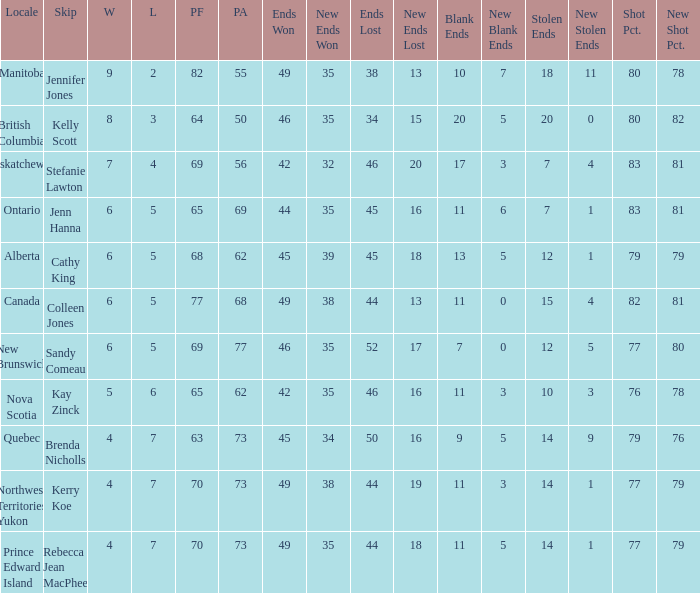What is the minimum PA when ends lost is 45? 62.0. Could you parse the entire table as a dict? {'header': ['Locale', 'Skip', 'W', 'L', 'PF', 'PA', 'Ends Won', 'New Ends Won', 'Ends Lost', 'New Ends Lost', 'Blank Ends', 'New Blank Ends', 'Stolen Ends', 'New Stolen Ends', 'Shot Pct.', 'New Shot Pct.'], 'rows': [['Manitoba', 'Jennifer Jones', '9', '2', '82', '55', '49', '35', '38', '13', '10', '7', '18', '11', '80', '78'], ['British Columbia', 'Kelly Scott', '8', '3', '64', '50', '46', '35', '34', '15', '20', '5', '20', '0', '80', '82'], ['Saskatchewan', 'Stefanie Lawton', '7', '4', '69', '56', '42', '32', '46', '20', '17', '3', '7', '4', '83', '81'], ['Ontario', 'Jenn Hanna', '6', '5', '65', '69', '44', '35', '45', '16', '11', '6', '7', '1', '83', '81'], ['Alberta', 'Cathy King', '6', '5', '68', '62', '45', '39', '45', '18', '13', '5', '12', '1', '79', '79'], ['Canada', 'Colleen Jones', '6', '5', '77', '68', '49', '38', '44', '13', '11', '0', '15', '4', '82', '81'], ['New Brunswick', 'Sandy Comeau', '6', '5', '69', '77', '46', '35', '52', '17', '7', '0', '12', '5', '77', '80'], ['Nova Scotia', 'Kay Zinck', '5', '6', '65', '62', '42', '35', '46', '16', '11', '3', '10', '3', '76', '78'], ['Quebec', 'Brenda Nicholls', '4', '7', '63', '73', '45', '34', '50', '16', '9', '5', '14', '9', '79', '76'], ['Northwest Territories Yukon', 'Kerry Koe', '4', '7', '70', '73', '49', '38', '44', '19', '11', '3', '14', '1', '77', '79'], ['Prince Edward Island', 'Rebecca Jean MacPhee', '4', '7', '70', '73', '49', '35', '44', '18', '11', '5', '14', '1', '77', '79']]} 